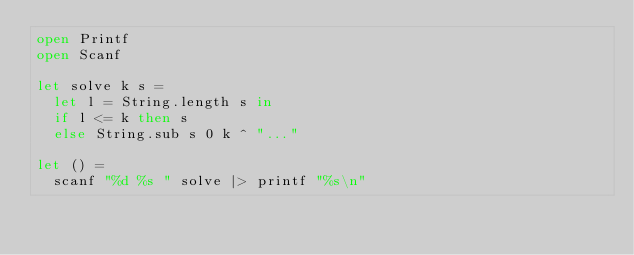Convert code to text. <code><loc_0><loc_0><loc_500><loc_500><_OCaml_>open Printf
open Scanf

let solve k s =
  let l = String.length s in
  if l <= k then s
  else String.sub s 0 k ^ "..."

let () =
  scanf "%d %s " solve |> printf "%s\n"
</code> 